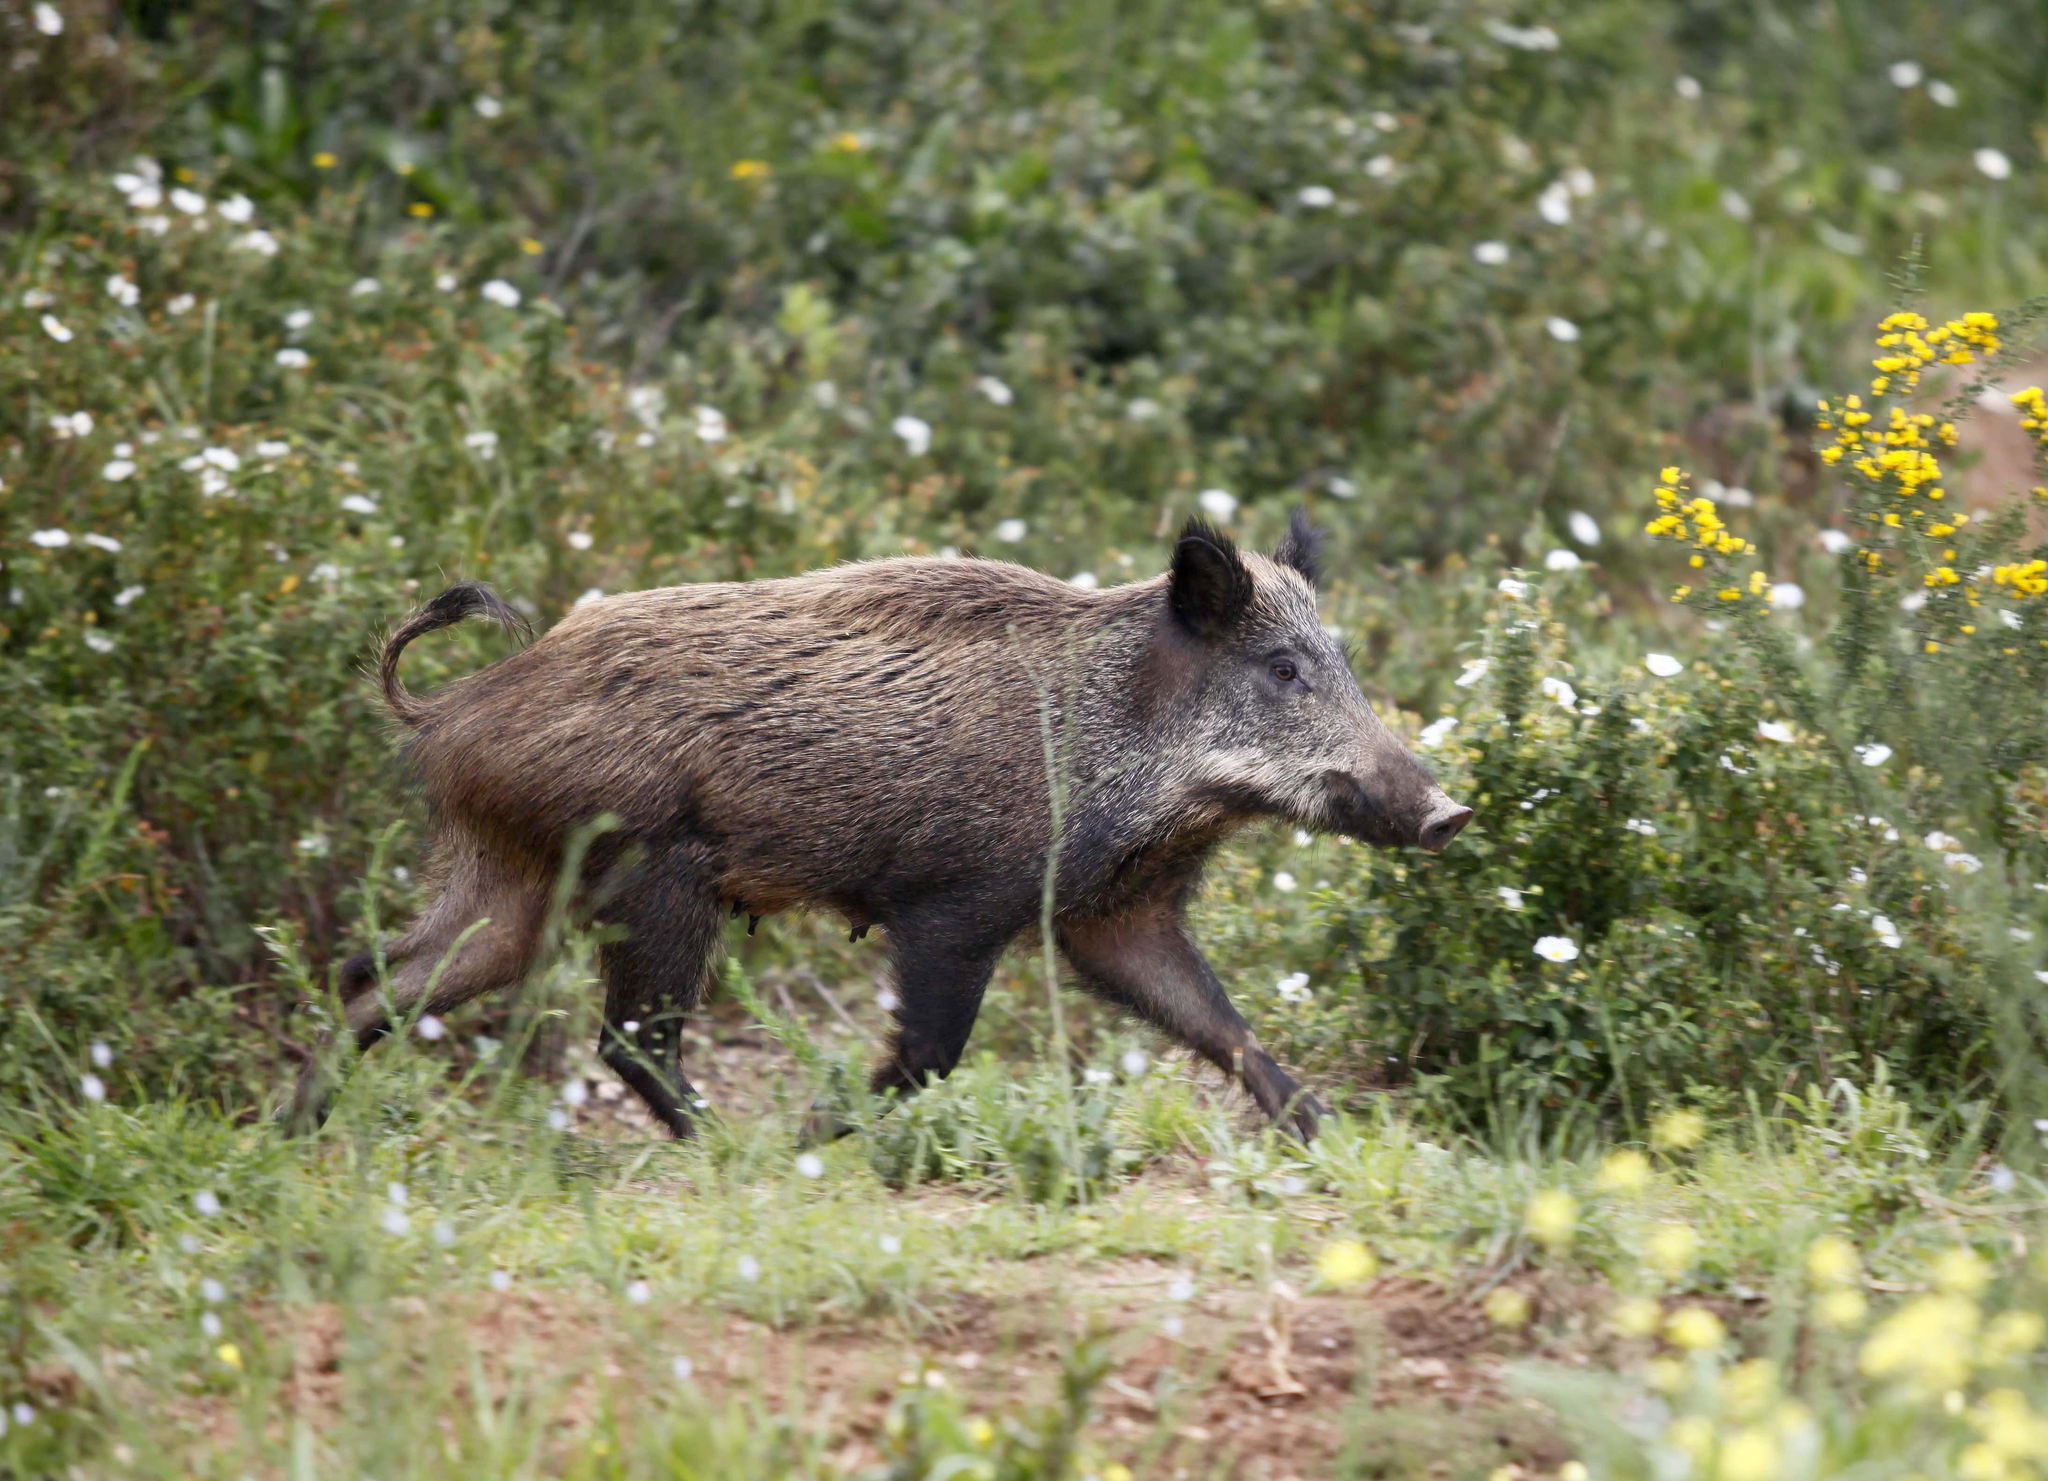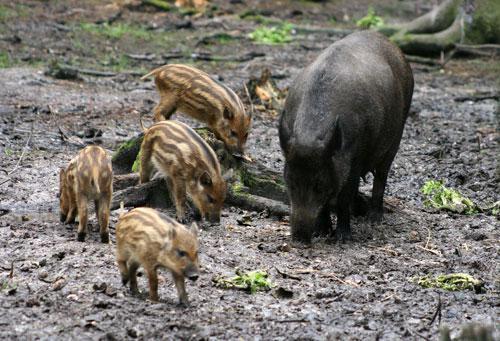The first image is the image on the left, the second image is the image on the right. Evaluate the accuracy of this statement regarding the images: "In one of the images there are two or more brown striped pigs.". Is it true? Answer yes or no. Yes. The first image is the image on the left, the second image is the image on the right. Analyze the images presented: Is the assertion "There is a single boar in the left image." valid? Answer yes or no. Yes. 